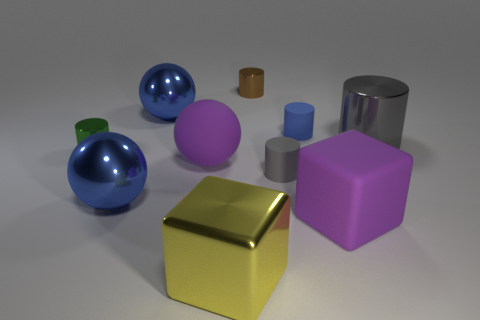Which object stands out the most due to its color? The golden cube stands out prominently due to its shiny, reflective surface and the distinct contrast it creates with the other, more subdued colors in the image. 